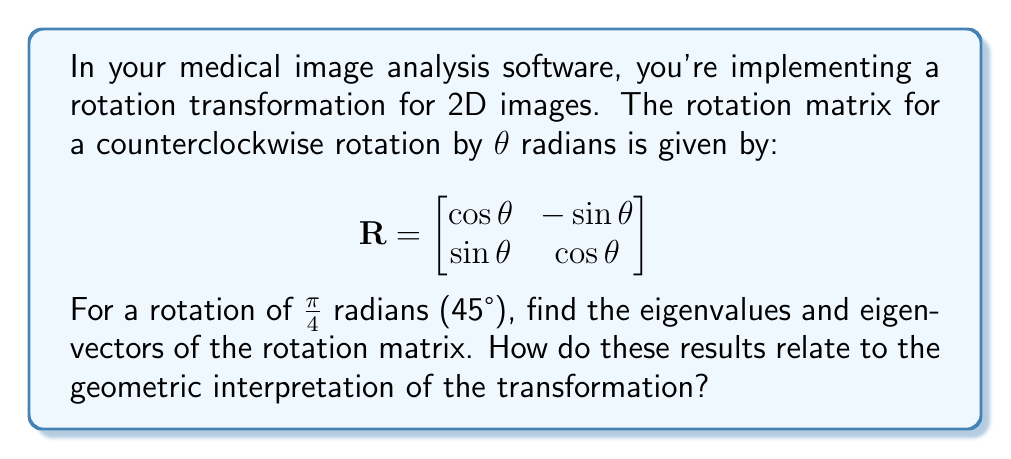Show me your answer to this math problem. 1) First, let's calculate the rotation matrix for θ = π/4:

$$R = \begin{bmatrix}
\cos(π/4) & -\sin(π/4) \\
\sin(π/4) & \cos(π/4)
\end{bmatrix} = \begin{bmatrix}
1/\sqrt{2} & -1/\sqrt{2} \\
1/\sqrt{2} & 1/\sqrt{2}
\end{bmatrix}$$

2) To find the eigenvalues, we solve the characteristic equation:
   $\det(R - λI) = 0$

$$\begin{vmatrix}
1/\sqrt{2} - λ & -1/\sqrt{2} \\
1/\sqrt{2} & 1/\sqrt{2} - λ
\end{vmatrix} = 0$$

3) Expanding the determinant:
   $(1/\sqrt{2} - λ)^2 + 1/2 = 0$
   $1/2 - \sqrt{2}λ + λ^2 + 1/2 = 0$
   $λ^2 - \sqrt{2}λ + 1 = 0$

4) Solving this quadratic equation:
   $λ = (\sqrt{2} ± i\sqrt{2})/2 = (\1 ± i)/\sqrt{2}$

5) The eigenvalues are:
   $λ_1 = (1 + i)/\sqrt{2}$ and $λ_2 = (1 - i)/\sqrt{2}$

6) For each eigenvalue, we can find the corresponding eigenvector by solving $(R - λI)v = 0$

7) For $λ_1 = (1 + i)/\sqrt{2}$:
   $\begin{bmatrix}
   1/\sqrt{2} - (1+i)/\sqrt{2} & -1/\sqrt{2} \\
   1/\sqrt{2} & 1/\sqrt{2} - (1+i)/\sqrt{2}
   \end{bmatrix}\begin{bmatrix}v_1 \\ v_2\end{bmatrix} = \begin{bmatrix}0 \\ 0\end{bmatrix}$

   Simplifying, we get: $v_2 = iv_1$

   So, an eigenvector for $λ_1$ is $v_1 = \begin{bmatrix}1 \\ i\end{bmatrix}$

8) Similarly, for $λ_2 = (1 - i)/\sqrt{2}$, we get an eigenvector $v_2 = \begin{bmatrix}1 \\ -i\end{bmatrix}$

9) Geometrically, these results show that:
   - The eigenvalues have magnitude 1, indicating that the rotation preserves distances.
   - The eigenvectors are complex, reflecting that no real vector is left unchanged by a non-trivial rotation.
   - The eigenvectors represent the rotation axis in the complex plane.
Answer: Eigenvalues: $λ_1 = (1 + i)/\sqrt{2}$, $λ_2 = (1 - i)/\sqrt{2}$
Eigenvectors: $v_1 = \begin{bmatrix}1 \\ i\end{bmatrix}$, $v_2 = \begin{bmatrix}1 \\ -i\end{bmatrix}$ 